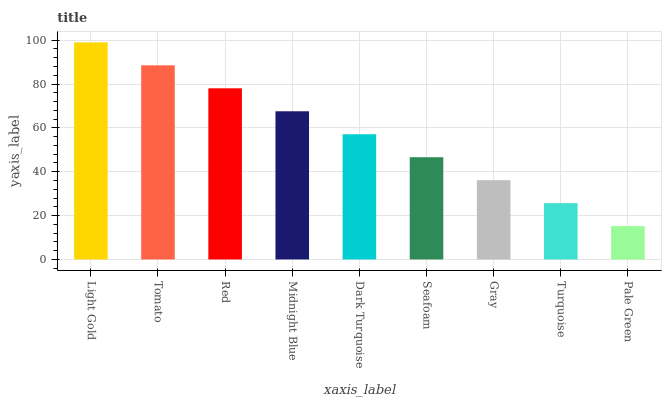Is Pale Green the minimum?
Answer yes or no. Yes. Is Light Gold the maximum?
Answer yes or no. Yes. Is Tomato the minimum?
Answer yes or no. No. Is Tomato the maximum?
Answer yes or no. No. Is Light Gold greater than Tomato?
Answer yes or no. Yes. Is Tomato less than Light Gold?
Answer yes or no. Yes. Is Tomato greater than Light Gold?
Answer yes or no. No. Is Light Gold less than Tomato?
Answer yes or no. No. Is Dark Turquoise the high median?
Answer yes or no. Yes. Is Dark Turquoise the low median?
Answer yes or no. Yes. Is Seafoam the high median?
Answer yes or no. No. Is Seafoam the low median?
Answer yes or no. No. 